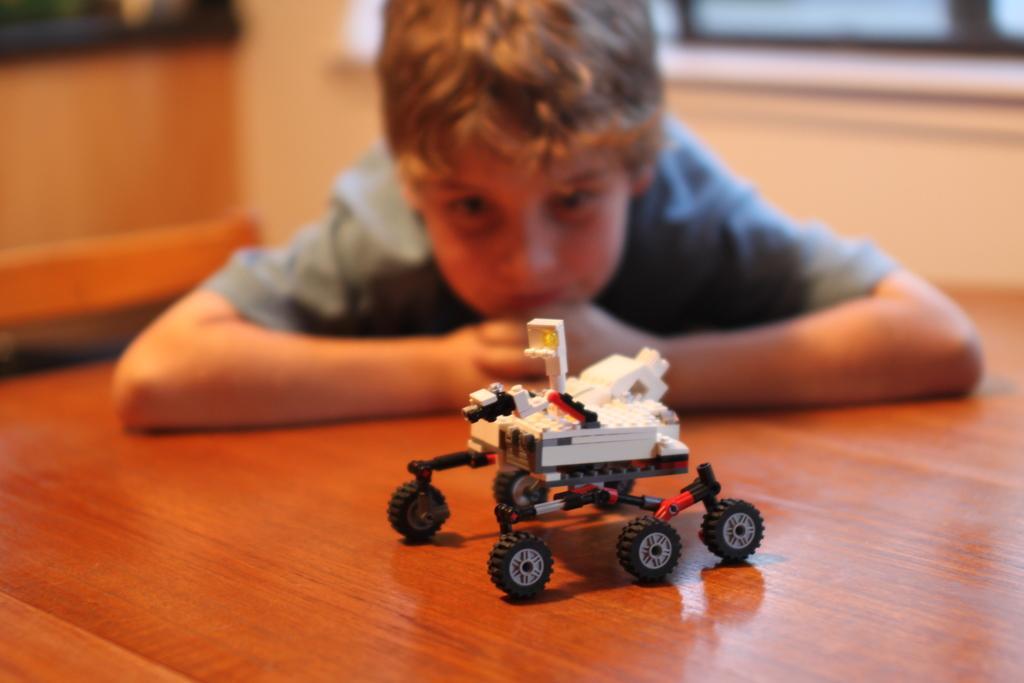Could you give a brief overview of what you see in this image? Here I can see a toy on the floor. In the background, I can see a boy wearing t-shirt, laying on the floor and looking at this toy. The background is blurred. 